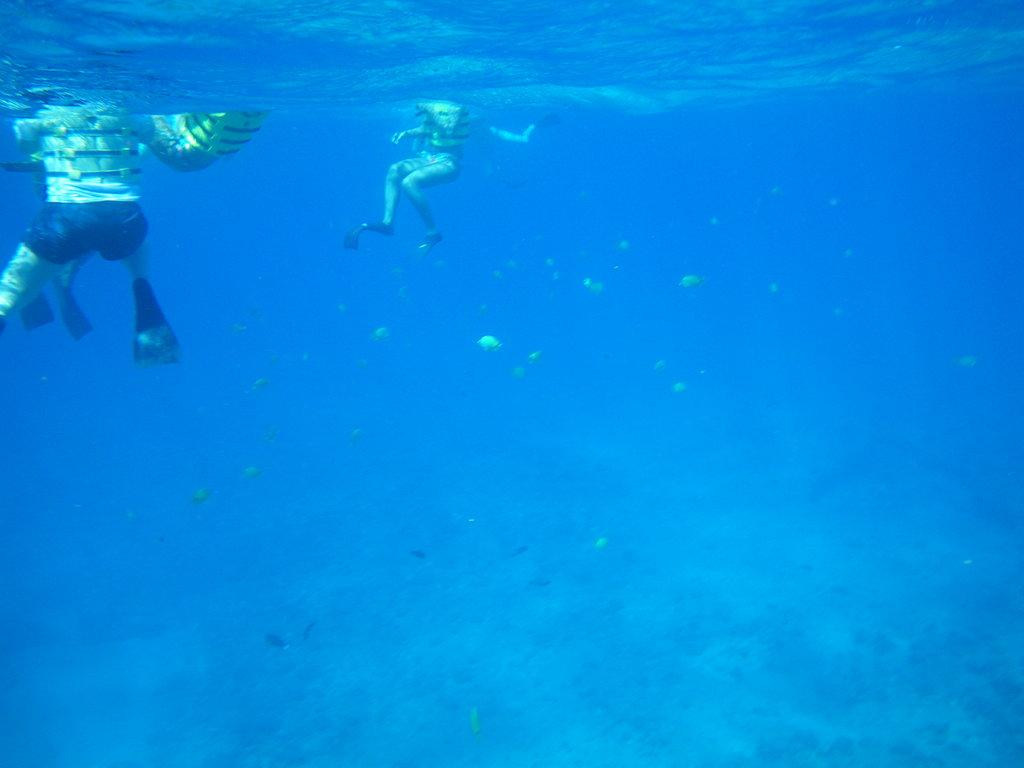What is the setting of the image? The image is underwater. What are the people in the image doing? The people in the image are swimming in the sea. What other creatures can be seen in the image? There are small fishes visible below the swimmers. What type of soda can be seen floating near the swimmers? There is no soda present in the image; it is set underwater in the sea. How deep is the harbor in the image? There is no harbor present in the image; it is set underwater in the sea. 